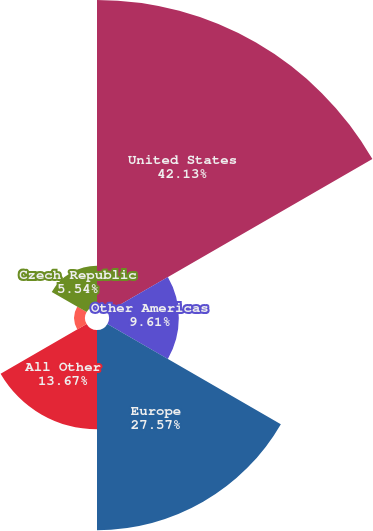<chart> <loc_0><loc_0><loc_500><loc_500><pie_chart><fcel>United States<fcel>Other Americas<fcel>Europe<fcel>All Other<fcel>Malaysia<fcel>Czech Republic<nl><fcel>42.12%<fcel>9.61%<fcel>27.57%<fcel>13.67%<fcel>1.48%<fcel>5.54%<nl></chart> 